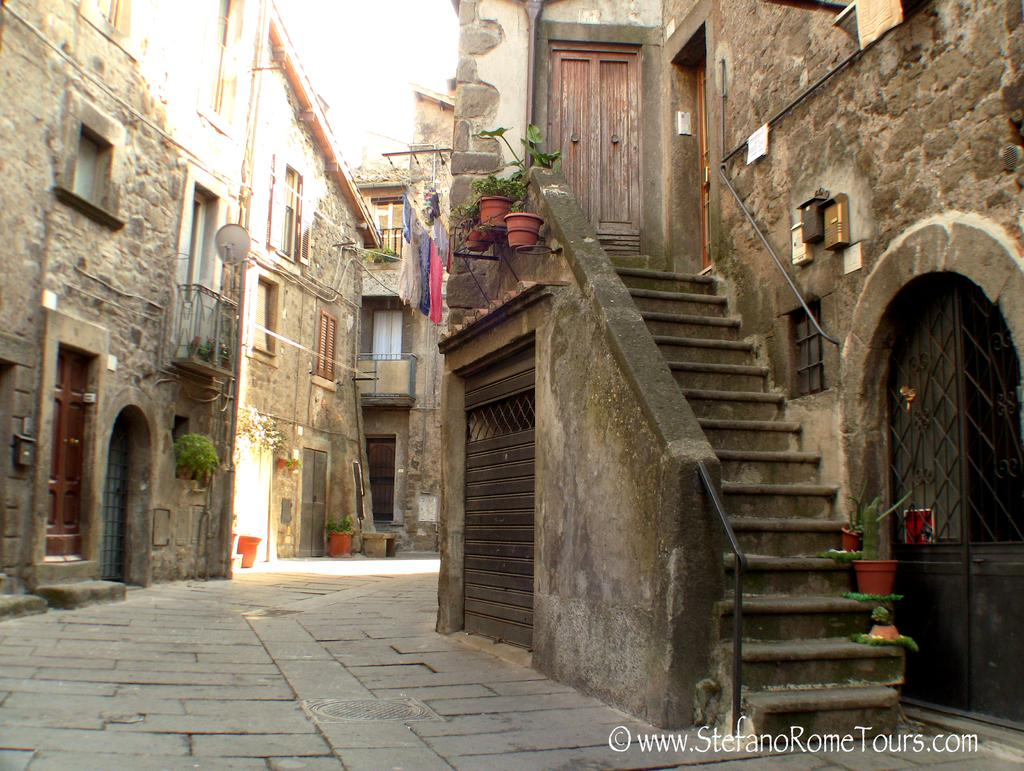What can be seen at the entrance of the building in the image? There are stairs leading into a building in the image. What are the characteristics of the buildings in the image? The buildings have doors and windows in the image. What type of decorative items are present in the image? There are flower pots in the image. What type of cork can be seen in the image? There is no cork present in the image. What error is being corrected in the image? There is no error being corrected in the image. 